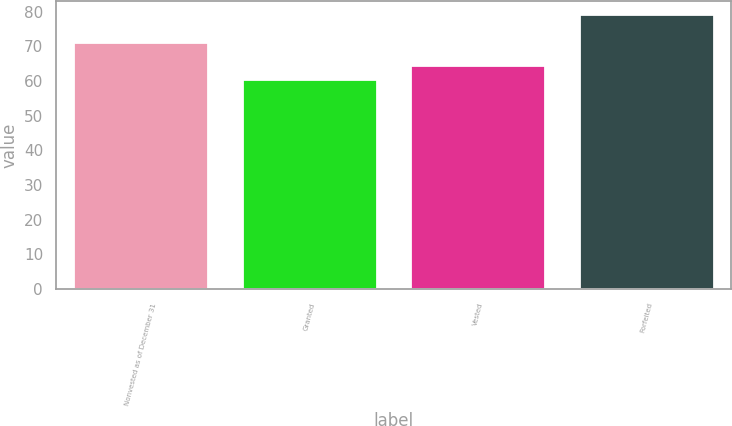Convert chart to OTSL. <chart><loc_0><loc_0><loc_500><loc_500><bar_chart><fcel>Nonvested as of December 31<fcel>Granted<fcel>Vested<fcel>Forfeited<nl><fcel>71.29<fcel>60.55<fcel>64.62<fcel>79.19<nl></chart> 